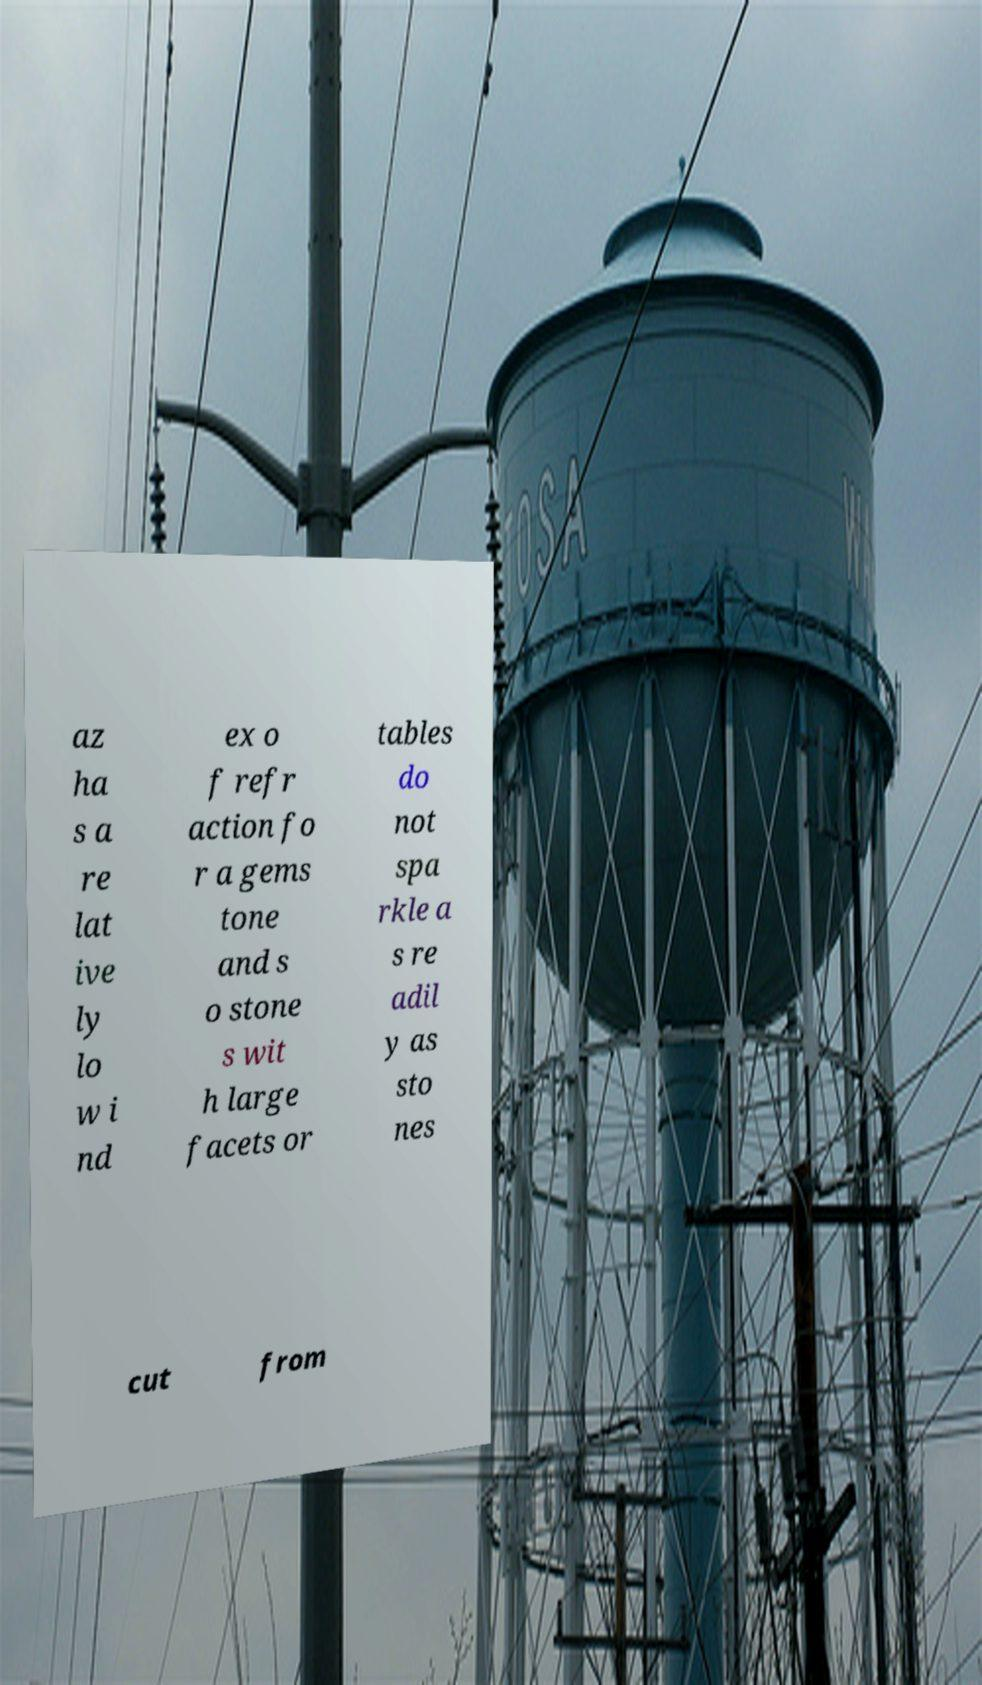Could you assist in decoding the text presented in this image and type it out clearly? az ha s a re lat ive ly lo w i nd ex o f refr action fo r a gems tone and s o stone s wit h large facets or tables do not spa rkle a s re adil y as sto nes cut from 